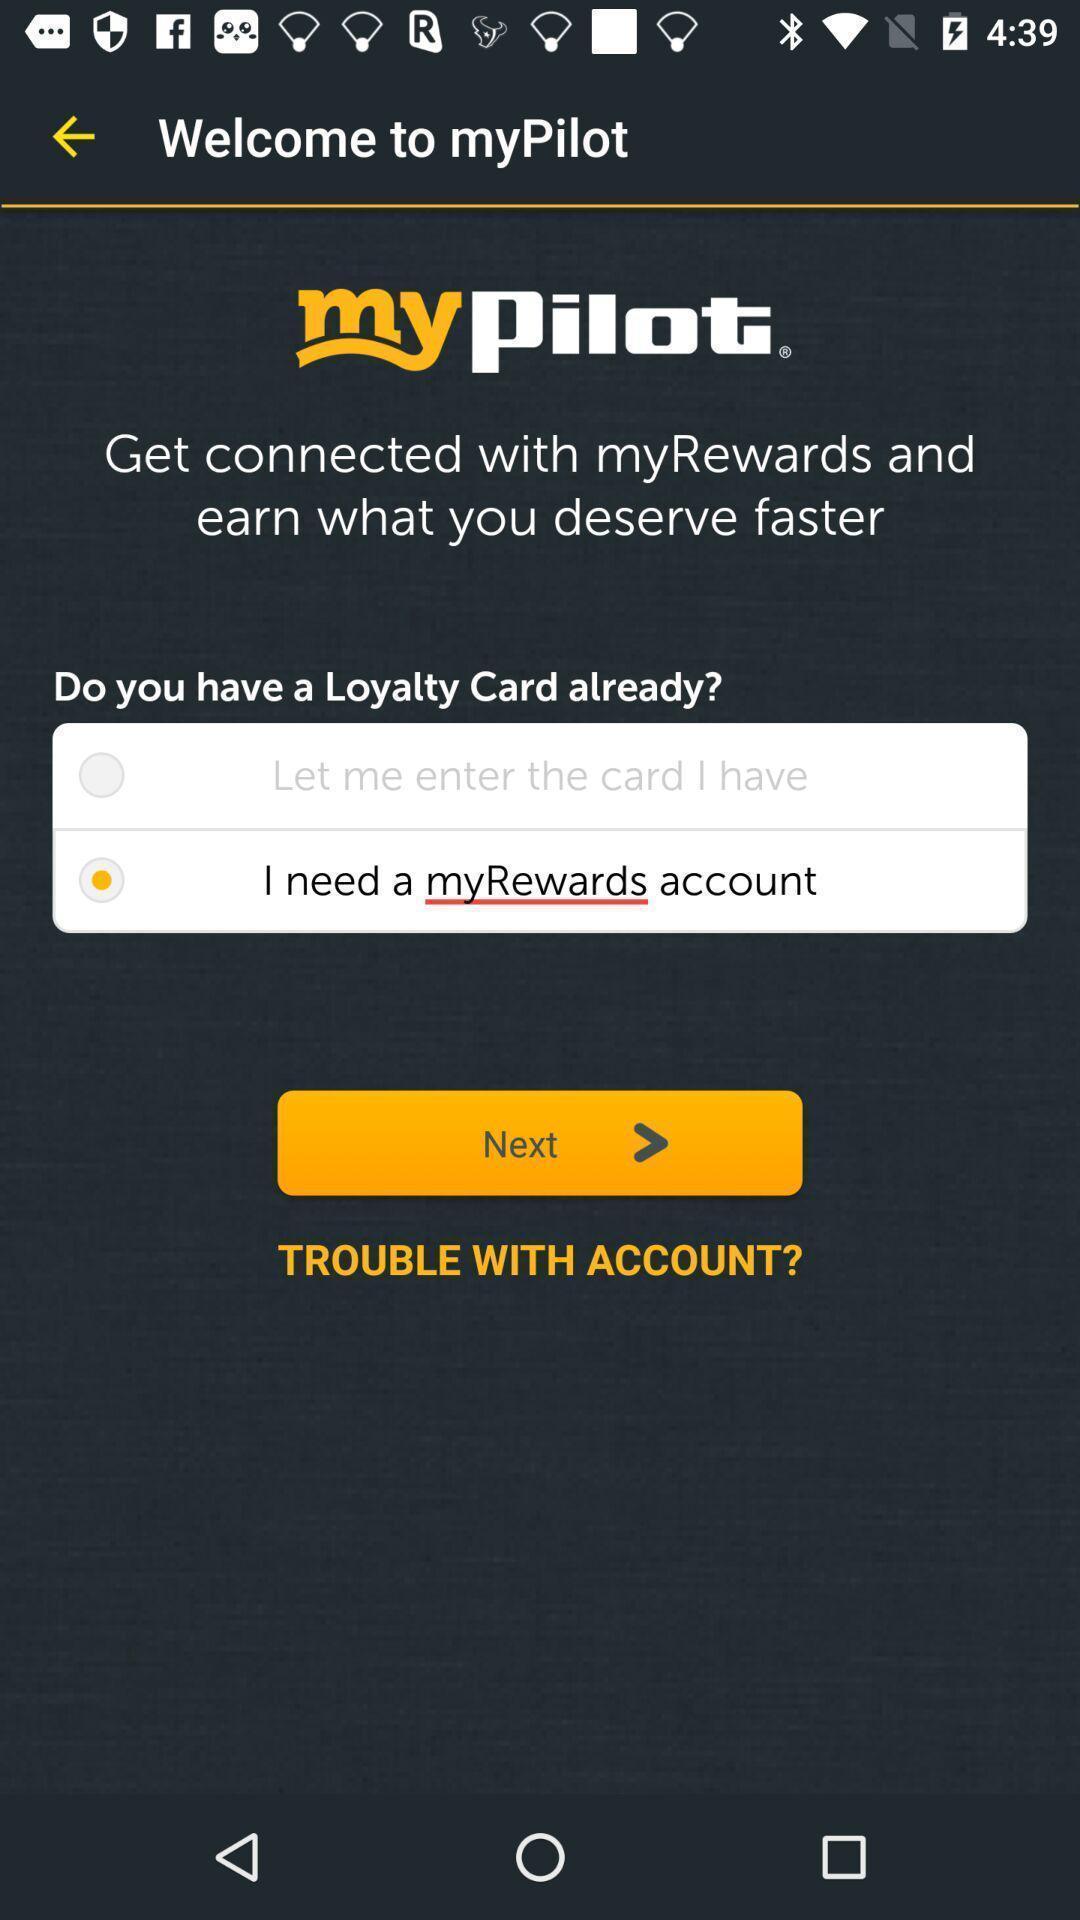Provide a description of this screenshot. Welcome page of an trip-planner app. 